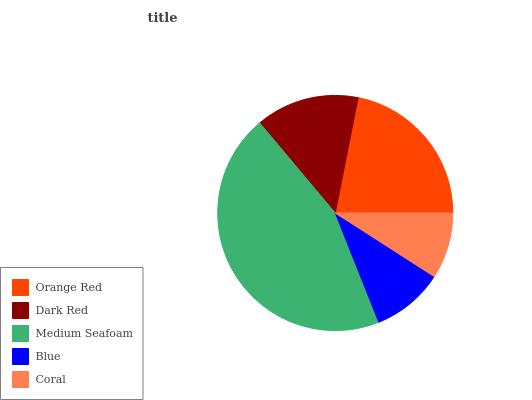Is Coral the minimum?
Answer yes or no. Yes. Is Medium Seafoam the maximum?
Answer yes or no. Yes. Is Dark Red the minimum?
Answer yes or no. No. Is Dark Red the maximum?
Answer yes or no. No. Is Orange Red greater than Dark Red?
Answer yes or no. Yes. Is Dark Red less than Orange Red?
Answer yes or no. Yes. Is Dark Red greater than Orange Red?
Answer yes or no. No. Is Orange Red less than Dark Red?
Answer yes or no. No. Is Dark Red the high median?
Answer yes or no. Yes. Is Dark Red the low median?
Answer yes or no. Yes. Is Blue the high median?
Answer yes or no. No. Is Coral the low median?
Answer yes or no. No. 